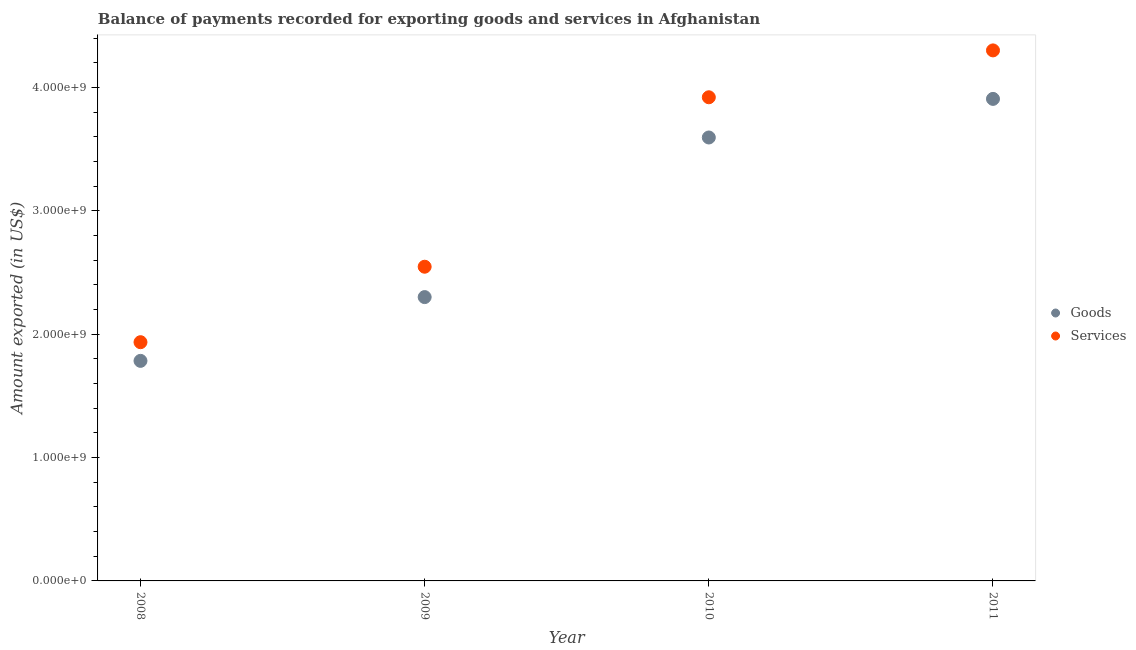How many different coloured dotlines are there?
Your answer should be very brief. 2. What is the amount of goods exported in 2008?
Your response must be concise. 1.78e+09. Across all years, what is the maximum amount of services exported?
Provide a short and direct response. 4.30e+09. Across all years, what is the minimum amount of goods exported?
Provide a short and direct response. 1.78e+09. In which year was the amount of services exported maximum?
Give a very brief answer. 2011. In which year was the amount of services exported minimum?
Offer a very short reply. 2008. What is the total amount of services exported in the graph?
Your response must be concise. 1.27e+1. What is the difference between the amount of services exported in 2008 and that in 2009?
Your response must be concise. -6.12e+08. What is the difference between the amount of goods exported in 2011 and the amount of services exported in 2008?
Offer a terse response. 1.97e+09. What is the average amount of services exported per year?
Make the answer very short. 3.18e+09. In the year 2011, what is the difference between the amount of goods exported and amount of services exported?
Keep it short and to the point. -3.93e+08. What is the ratio of the amount of services exported in 2008 to that in 2011?
Provide a short and direct response. 0.45. Is the amount of services exported in 2008 less than that in 2009?
Offer a terse response. Yes. What is the difference between the highest and the second highest amount of goods exported?
Provide a short and direct response. 3.13e+08. What is the difference between the highest and the lowest amount of services exported?
Your response must be concise. 2.36e+09. Is the sum of the amount of goods exported in 2010 and 2011 greater than the maximum amount of services exported across all years?
Your response must be concise. Yes. Is the amount of goods exported strictly less than the amount of services exported over the years?
Ensure brevity in your answer.  Yes. Does the graph contain any zero values?
Ensure brevity in your answer.  No. Does the graph contain grids?
Provide a succinct answer. No. Where does the legend appear in the graph?
Keep it short and to the point. Center right. How many legend labels are there?
Provide a succinct answer. 2. What is the title of the graph?
Offer a terse response. Balance of payments recorded for exporting goods and services in Afghanistan. Does "Unregistered firms" appear as one of the legend labels in the graph?
Your answer should be very brief. No. What is the label or title of the Y-axis?
Provide a short and direct response. Amount exported (in US$). What is the Amount exported (in US$) of Goods in 2008?
Offer a terse response. 1.78e+09. What is the Amount exported (in US$) of Services in 2008?
Offer a very short reply. 1.93e+09. What is the Amount exported (in US$) in Goods in 2009?
Your answer should be very brief. 2.30e+09. What is the Amount exported (in US$) of Services in 2009?
Your response must be concise. 2.55e+09. What is the Amount exported (in US$) of Goods in 2010?
Give a very brief answer. 3.59e+09. What is the Amount exported (in US$) in Services in 2010?
Give a very brief answer. 3.92e+09. What is the Amount exported (in US$) of Goods in 2011?
Your answer should be compact. 3.91e+09. What is the Amount exported (in US$) in Services in 2011?
Offer a terse response. 4.30e+09. Across all years, what is the maximum Amount exported (in US$) in Goods?
Keep it short and to the point. 3.91e+09. Across all years, what is the maximum Amount exported (in US$) in Services?
Keep it short and to the point. 4.30e+09. Across all years, what is the minimum Amount exported (in US$) in Goods?
Offer a very short reply. 1.78e+09. Across all years, what is the minimum Amount exported (in US$) in Services?
Provide a short and direct response. 1.93e+09. What is the total Amount exported (in US$) in Goods in the graph?
Ensure brevity in your answer.  1.16e+1. What is the total Amount exported (in US$) of Services in the graph?
Make the answer very short. 1.27e+1. What is the difference between the Amount exported (in US$) of Goods in 2008 and that in 2009?
Keep it short and to the point. -5.17e+08. What is the difference between the Amount exported (in US$) in Services in 2008 and that in 2009?
Provide a succinct answer. -6.12e+08. What is the difference between the Amount exported (in US$) of Goods in 2008 and that in 2010?
Keep it short and to the point. -1.81e+09. What is the difference between the Amount exported (in US$) of Services in 2008 and that in 2010?
Keep it short and to the point. -1.98e+09. What is the difference between the Amount exported (in US$) in Goods in 2008 and that in 2011?
Offer a very short reply. -2.12e+09. What is the difference between the Amount exported (in US$) in Services in 2008 and that in 2011?
Provide a succinct answer. -2.36e+09. What is the difference between the Amount exported (in US$) in Goods in 2009 and that in 2010?
Offer a very short reply. -1.29e+09. What is the difference between the Amount exported (in US$) of Services in 2009 and that in 2010?
Make the answer very short. -1.37e+09. What is the difference between the Amount exported (in US$) in Goods in 2009 and that in 2011?
Provide a short and direct response. -1.61e+09. What is the difference between the Amount exported (in US$) of Services in 2009 and that in 2011?
Keep it short and to the point. -1.75e+09. What is the difference between the Amount exported (in US$) in Goods in 2010 and that in 2011?
Your answer should be very brief. -3.13e+08. What is the difference between the Amount exported (in US$) in Services in 2010 and that in 2011?
Your answer should be compact. -3.80e+08. What is the difference between the Amount exported (in US$) in Goods in 2008 and the Amount exported (in US$) in Services in 2009?
Your answer should be compact. -7.63e+08. What is the difference between the Amount exported (in US$) of Goods in 2008 and the Amount exported (in US$) of Services in 2010?
Offer a very short reply. -2.14e+09. What is the difference between the Amount exported (in US$) in Goods in 2008 and the Amount exported (in US$) in Services in 2011?
Make the answer very short. -2.52e+09. What is the difference between the Amount exported (in US$) in Goods in 2009 and the Amount exported (in US$) in Services in 2010?
Provide a succinct answer. -1.62e+09. What is the difference between the Amount exported (in US$) in Goods in 2009 and the Amount exported (in US$) in Services in 2011?
Offer a terse response. -2.00e+09. What is the difference between the Amount exported (in US$) of Goods in 2010 and the Amount exported (in US$) of Services in 2011?
Offer a terse response. -7.06e+08. What is the average Amount exported (in US$) of Goods per year?
Make the answer very short. 2.90e+09. What is the average Amount exported (in US$) in Services per year?
Keep it short and to the point. 3.18e+09. In the year 2008, what is the difference between the Amount exported (in US$) of Goods and Amount exported (in US$) of Services?
Provide a short and direct response. -1.51e+08. In the year 2009, what is the difference between the Amount exported (in US$) in Goods and Amount exported (in US$) in Services?
Give a very brief answer. -2.46e+08. In the year 2010, what is the difference between the Amount exported (in US$) in Goods and Amount exported (in US$) in Services?
Give a very brief answer. -3.26e+08. In the year 2011, what is the difference between the Amount exported (in US$) in Goods and Amount exported (in US$) in Services?
Offer a very short reply. -3.93e+08. What is the ratio of the Amount exported (in US$) in Goods in 2008 to that in 2009?
Provide a succinct answer. 0.78. What is the ratio of the Amount exported (in US$) in Services in 2008 to that in 2009?
Offer a very short reply. 0.76. What is the ratio of the Amount exported (in US$) in Goods in 2008 to that in 2010?
Give a very brief answer. 0.5. What is the ratio of the Amount exported (in US$) of Services in 2008 to that in 2010?
Provide a succinct answer. 0.49. What is the ratio of the Amount exported (in US$) of Goods in 2008 to that in 2011?
Offer a very short reply. 0.46. What is the ratio of the Amount exported (in US$) in Services in 2008 to that in 2011?
Provide a short and direct response. 0.45. What is the ratio of the Amount exported (in US$) of Goods in 2009 to that in 2010?
Offer a terse response. 0.64. What is the ratio of the Amount exported (in US$) in Services in 2009 to that in 2010?
Offer a terse response. 0.65. What is the ratio of the Amount exported (in US$) in Goods in 2009 to that in 2011?
Give a very brief answer. 0.59. What is the ratio of the Amount exported (in US$) in Services in 2009 to that in 2011?
Your answer should be compact. 0.59. What is the ratio of the Amount exported (in US$) in Goods in 2010 to that in 2011?
Provide a short and direct response. 0.92. What is the ratio of the Amount exported (in US$) of Services in 2010 to that in 2011?
Make the answer very short. 0.91. What is the difference between the highest and the second highest Amount exported (in US$) of Goods?
Make the answer very short. 3.13e+08. What is the difference between the highest and the second highest Amount exported (in US$) of Services?
Provide a succinct answer. 3.80e+08. What is the difference between the highest and the lowest Amount exported (in US$) of Goods?
Keep it short and to the point. 2.12e+09. What is the difference between the highest and the lowest Amount exported (in US$) of Services?
Offer a very short reply. 2.36e+09. 